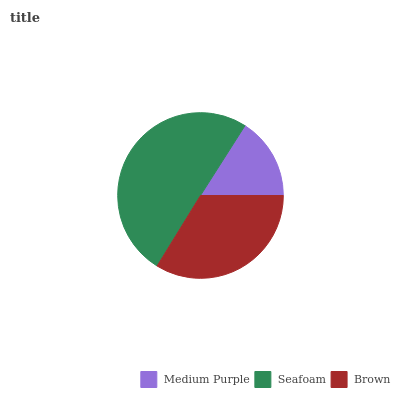Is Medium Purple the minimum?
Answer yes or no. Yes. Is Seafoam the maximum?
Answer yes or no. Yes. Is Brown the minimum?
Answer yes or no. No. Is Brown the maximum?
Answer yes or no. No. Is Seafoam greater than Brown?
Answer yes or no. Yes. Is Brown less than Seafoam?
Answer yes or no. Yes. Is Brown greater than Seafoam?
Answer yes or no. No. Is Seafoam less than Brown?
Answer yes or no. No. Is Brown the high median?
Answer yes or no. Yes. Is Brown the low median?
Answer yes or no. Yes. Is Medium Purple the high median?
Answer yes or no. No. Is Seafoam the low median?
Answer yes or no. No. 